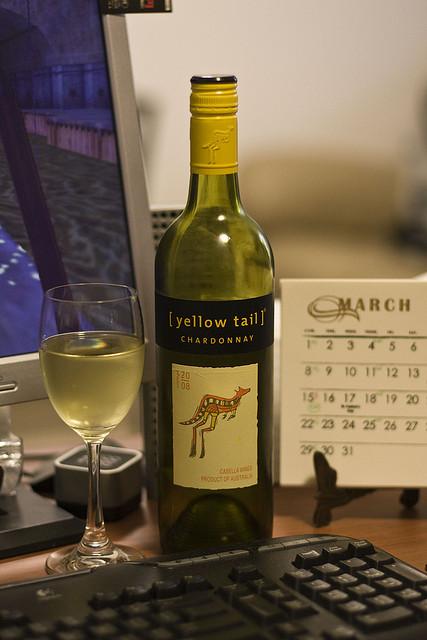What brand is wine?
Keep it brief. Yellow tail. Where is the window?
Answer briefly. No. Is the wine glass empty?
Concise answer only. No. What does the writing on the mat indicate?
Answer briefly. Month. How many bottles are there?
Be succinct. 1. What brand of drink is this?
Give a very brief answer. Yellow tail. How many bottles are on the table?
Answer briefly. 1. What is the paper on the table for?
Write a very short answer. Calendar. What brand of wine is this?
Be succinct. Yellow tail. What are they probably drinking?
Keep it brief. Wine. Is this French wine?
Short answer required. No. What are featured?
Answer briefly. Wine. What animal is on the wine bottle?
Concise answer only. Kangaroo. Is there a cd in the photo?
Quick response, please. No. What month is on the calendar?
Short answer required. March. 